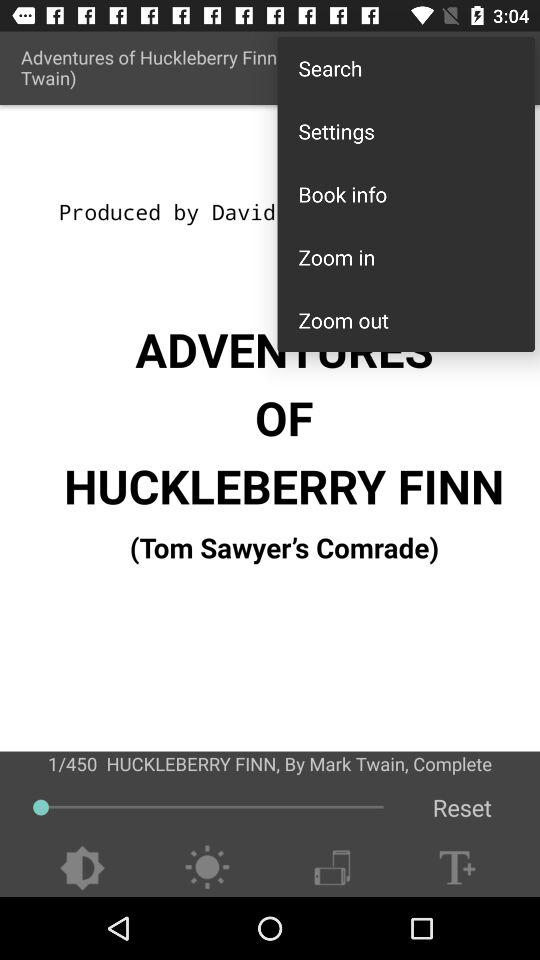What is the Address?
When the provided information is insufficient, respond with <no answer>. <no answer> 